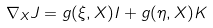<formula> <loc_0><loc_0><loc_500><loc_500>\nabla _ { X } J = g ( \xi , X ) I + g ( \eta , X ) K</formula> 